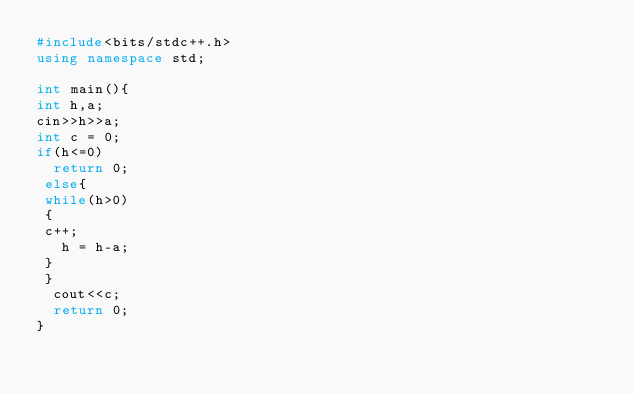Convert code to text. <code><loc_0><loc_0><loc_500><loc_500><_C++_>#include<bits/stdc++.h>
using namespace std;

int main(){
int h,a;
cin>>h>>a;
int c = 0;
if(h<=0)
  return 0;
 else{
 while(h>0)
 {
 c++;
   h = h-a;
 }
 }
  cout<<c;
  return 0;
}</code> 